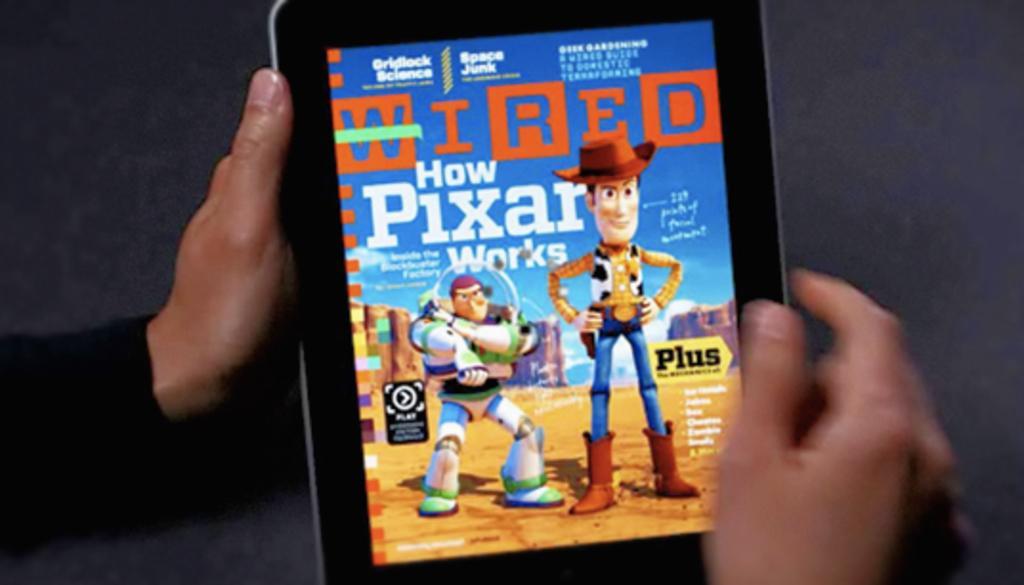Describe this image in one or two sentences. In this picture we can see a person is holding a tablet and the on the screen there are some toy images. 